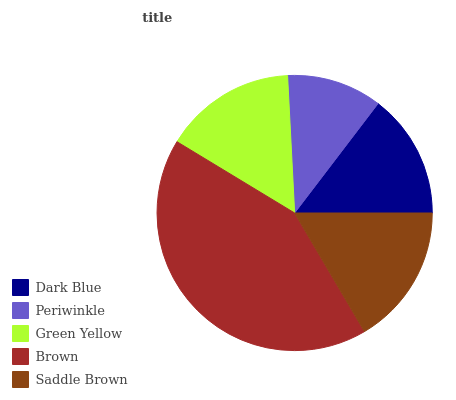Is Periwinkle the minimum?
Answer yes or no. Yes. Is Brown the maximum?
Answer yes or no. Yes. Is Green Yellow the minimum?
Answer yes or no. No. Is Green Yellow the maximum?
Answer yes or no. No. Is Green Yellow greater than Periwinkle?
Answer yes or no. Yes. Is Periwinkle less than Green Yellow?
Answer yes or no. Yes. Is Periwinkle greater than Green Yellow?
Answer yes or no. No. Is Green Yellow less than Periwinkle?
Answer yes or no. No. Is Green Yellow the high median?
Answer yes or no. Yes. Is Green Yellow the low median?
Answer yes or no. Yes. Is Saddle Brown the high median?
Answer yes or no. No. Is Dark Blue the low median?
Answer yes or no. No. 